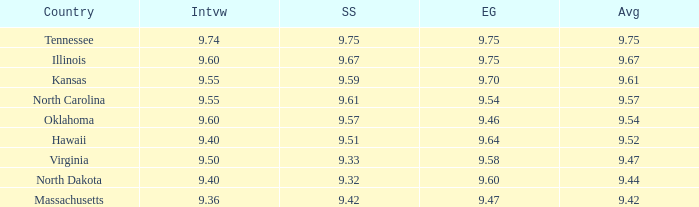What was the interview score for Hawaii? 9.4. 